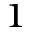<formula> <loc_0><loc_0><loc_500><loc_500>^ { 1 }</formula> 